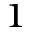<formula> <loc_0><loc_0><loc_500><loc_500>^ { 1 }</formula> 